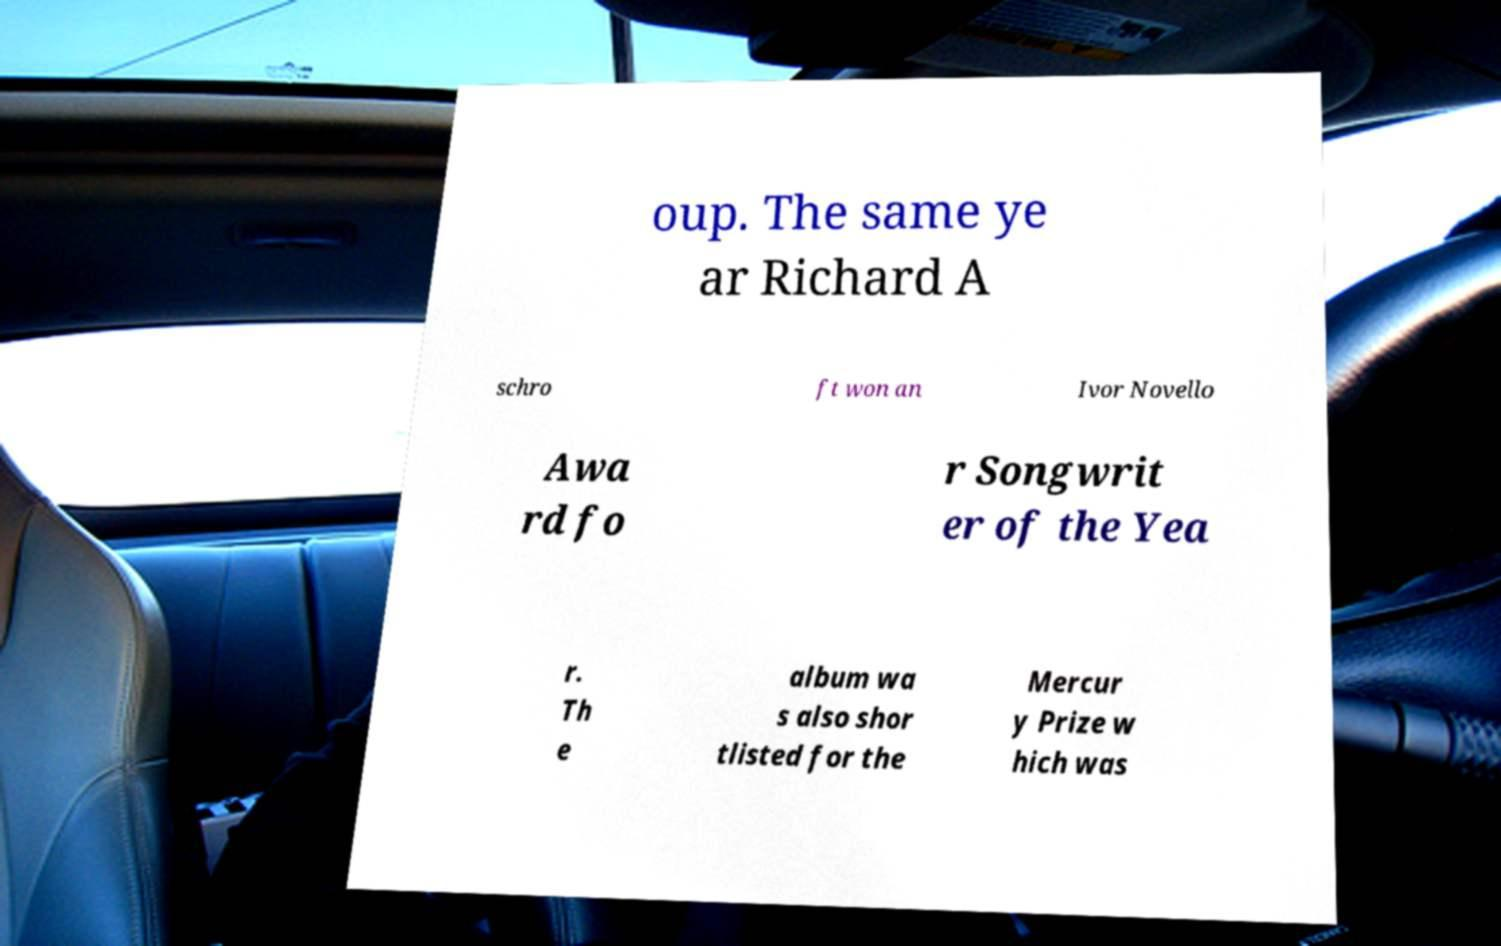I need the written content from this picture converted into text. Can you do that? oup. The same ye ar Richard A schro ft won an Ivor Novello Awa rd fo r Songwrit er of the Yea r. Th e album wa s also shor tlisted for the Mercur y Prize w hich was 